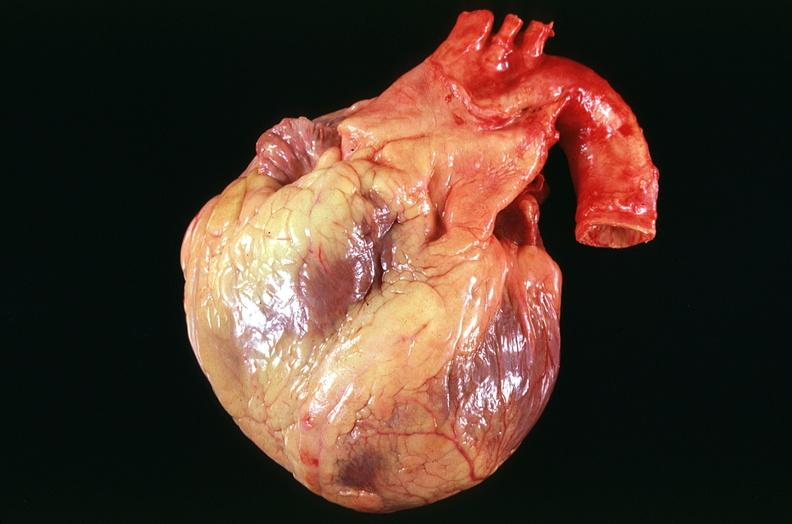s cardiovascular present?
Answer the question using a single word or phrase. Yes 